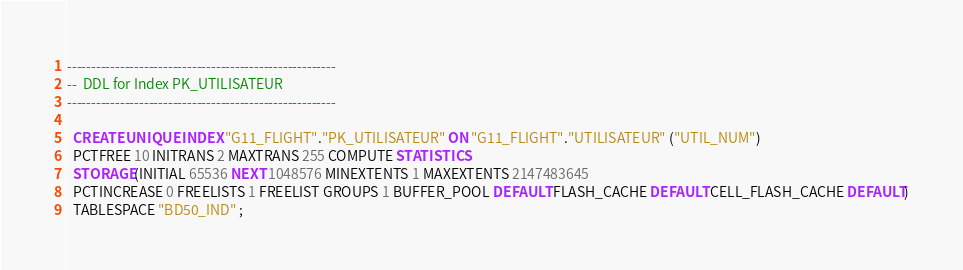<code> <loc_0><loc_0><loc_500><loc_500><_SQL_>--------------------------------------------------------
--  DDL for Index PK_UTILISATEUR
--------------------------------------------------------

  CREATE UNIQUE INDEX "G11_FLIGHT"."PK_UTILISATEUR" ON "G11_FLIGHT"."UTILISATEUR" ("UTIL_NUM") 
  PCTFREE 10 INITRANS 2 MAXTRANS 255 COMPUTE STATISTICS 
  STORAGE(INITIAL 65536 NEXT 1048576 MINEXTENTS 1 MAXEXTENTS 2147483645
  PCTINCREASE 0 FREELISTS 1 FREELIST GROUPS 1 BUFFER_POOL DEFAULT FLASH_CACHE DEFAULT CELL_FLASH_CACHE DEFAULT)
  TABLESPACE "BD50_IND" ;
</code> 